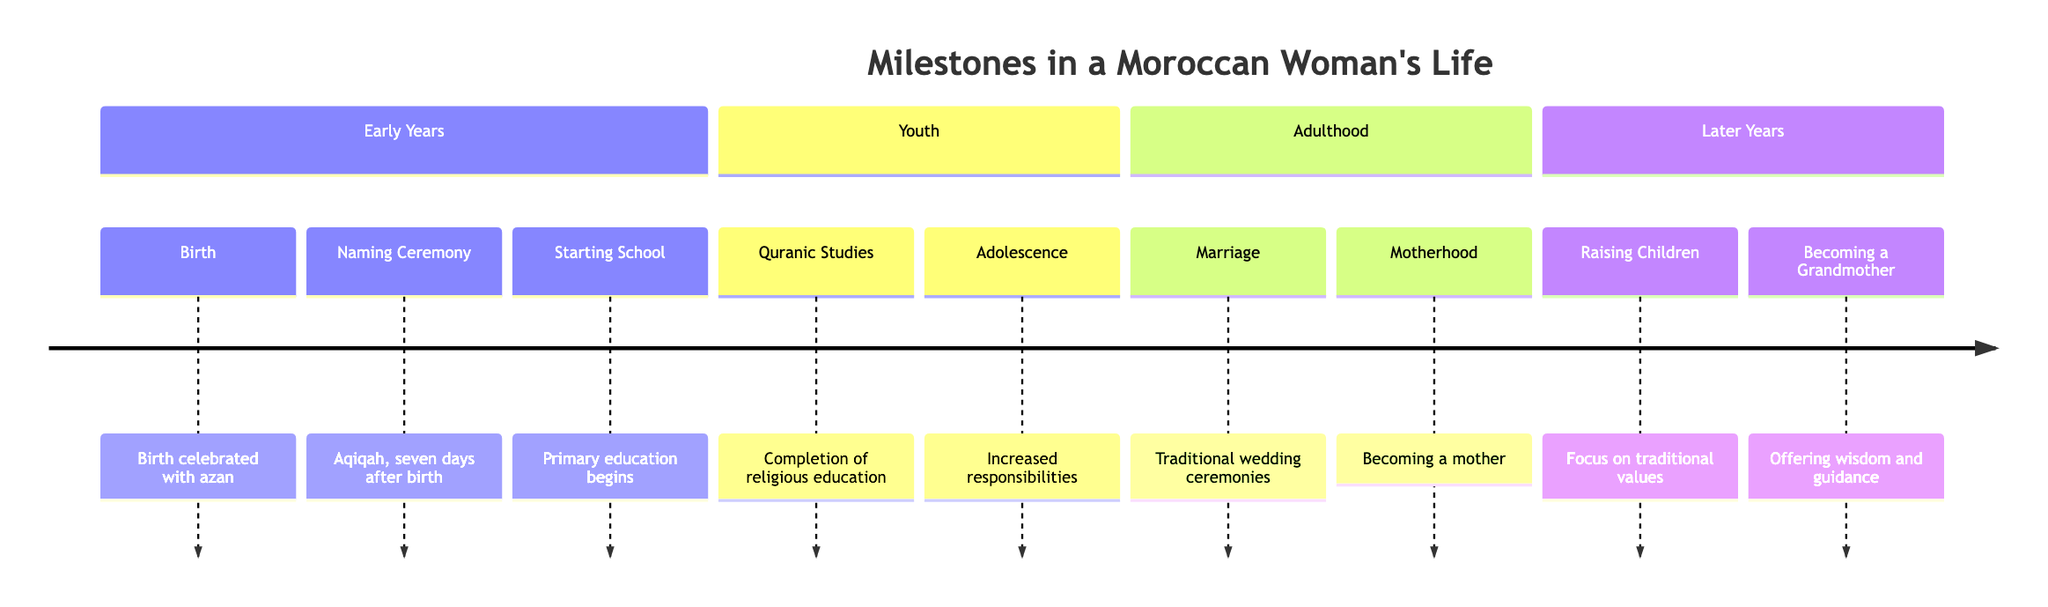What is the first milestone in a Moroccan woman's life? The diagram indicates that the first milestone is "Birth," which is celebrated with azan and family gatherings.
Answer: Birth How many major sections are in the timeline? The diagram has four major sections labeled: Early Years, Youth, Adulthood, and Later Years.
Answer: Four What milestone is associated with traditional wedding ceremonies? The milestone linked to traditional wedding ceremonies is "Marriage," as stated in the Adulthood section.
Answer: Marriage What comes after the completion of Quranic Studies? Following the completion of Quranic Studies, the next milestone is "Adolescence," which involves increased responsibilities.
Answer: Adolescence What role does a woman assume after becoming a mother? After becoming a mother, a woman takes on the role of nurturing and educational force for her children, as described in the diagram.
Answer: Nurturing How many steps are there from birth to becoming a grandmother? Analyzing the timeline, there are a total of eight milestones from "Birth" to "Becoming a Grandmother."
Answer: Eight What milestone indicates the transition to adult life? The milestone that signifies the transition to adult life is "Marriage," marking the entry into married life after adolescence.
Answer: Marriage Which milestone emphasizes raising children according to traditional values? The milestone that emphasizes raising children traditionally is "Raising Children," which focuses on academic and religious education.
Answer: Raising Children 